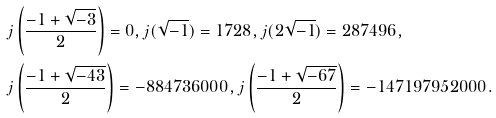<formula> <loc_0><loc_0><loc_500><loc_500>& j \left ( \frac { - 1 + \sqrt { - 3 } } { 2 } \right ) = 0 , j ( \sqrt { - 1 } ) = 1 7 2 8 , j ( 2 \sqrt { - 1 } ) = 2 8 7 4 9 6 , \\ & j \left ( \frac { - 1 + \sqrt { - 4 3 } } { 2 } \right ) = - 8 8 4 7 3 6 0 0 0 , j \left ( \frac { - 1 + \sqrt { - 6 7 } } { 2 } \right ) = - 1 4 7 1 9 7 9 5 2 0 0 0 .</formula> 